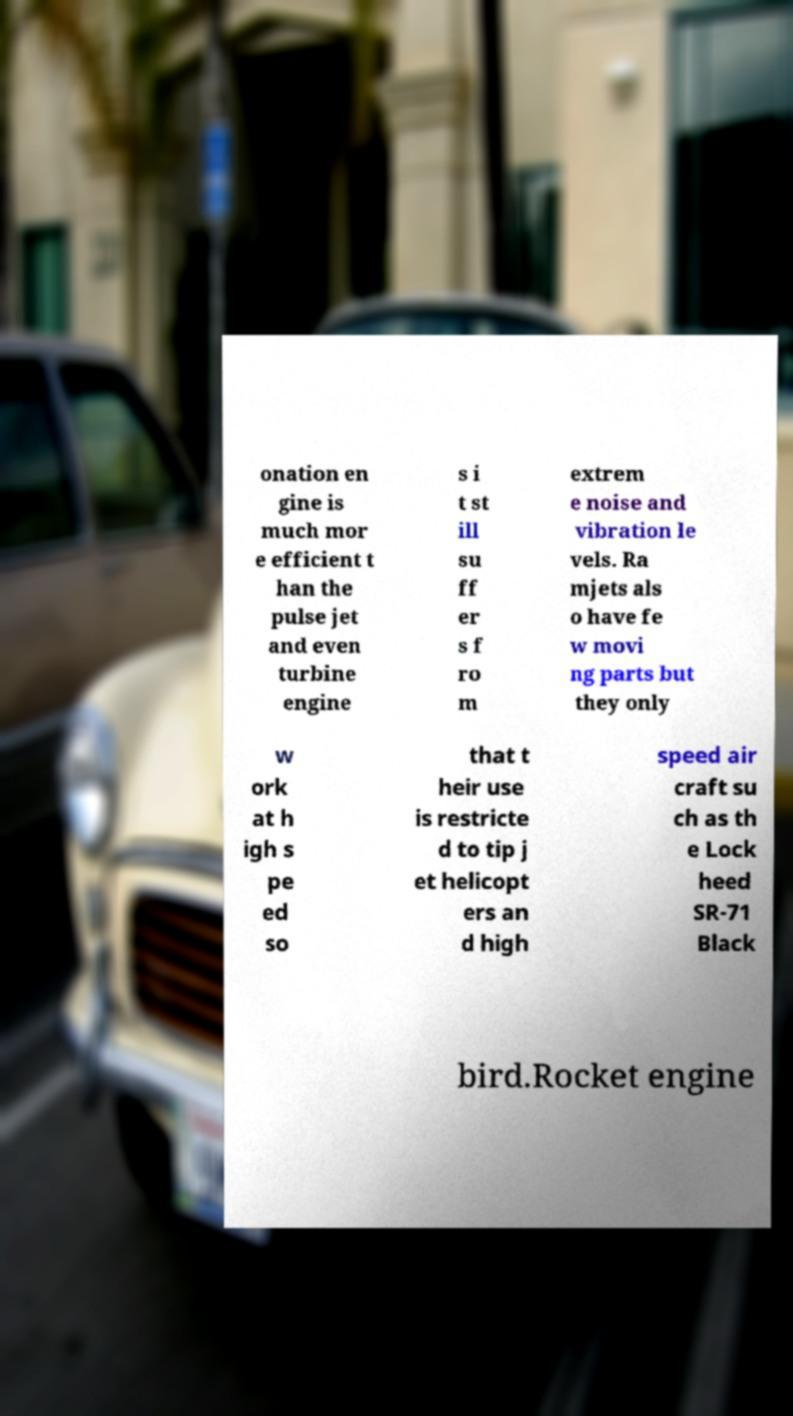Can you accurately transcribe the text from the provided image for me? onation en gine is much mor e efficient t han the pulse jet and even turbine engine s i t st ill su ff er s f ro m extrem e noise and vibration le vels. Ra mjets als o have fe w movi ng parts but they only w ork at h igh s pe ed so that t heir use is restricte d to tip j et helicopt ers an d high speed air craft su ch as th e Lock heed SR-71 Black bird.Rocket engine 